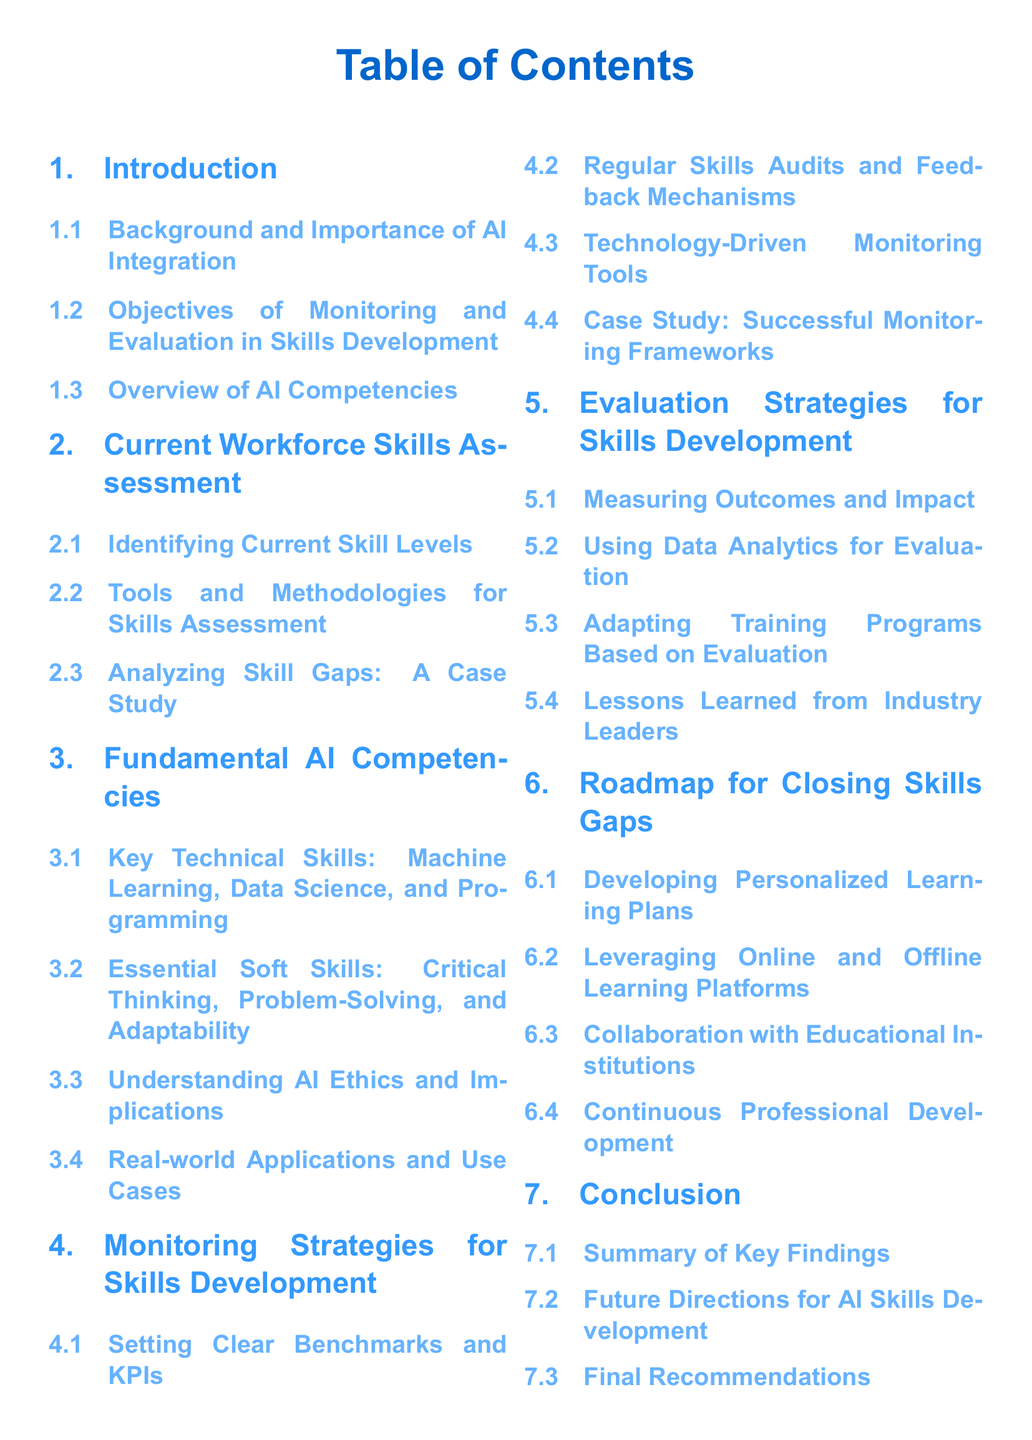What is the first section title in the document? The first section title is defined in the table of contents, which is "Introduction."
Answer: Introduction How many subsections are under "Current Workforce Skills Assessment"? The number of subsections is determined by counting the entries under that section, which are three.
Answer: 3 What are the key technical skills mentioned in the "Fundamental AI Competencies"? The key technical skills are listed as "Machine Learning, Data Science, and Programming."
Answer: Machine Learning, Data Science, and Programming What is the last subsection title under "Conclusion"? The last subsection title is derived from the document structure, which is "Final Recommendations."
Answer: Final Recommendations How many sections are there in total in the document? The total number of sections is counted from the table of contents, and there are seven.
Answer: 7 What type of tools are discussed under "Monitoring Strategies for Skills Development"? The type of tools mentioned reflects the subsections under that section, specifically "Technology-Driven Monitoring Tools."
Answer: Technology-Driven Monitoring Tools What is the focus of the section titled "Evaluation Strategies for Skills Development"? The focus is identified from the section title and discussed subsections, which cover measuring and adapting based on evaluation outcomes.
Answer: Measuring Outcomes and Impact What is the color used for section titles in the document? The color specified for section titles is referenced in the code, which is RGB(51,153,255).
Answer: RGB(51,153,255) 